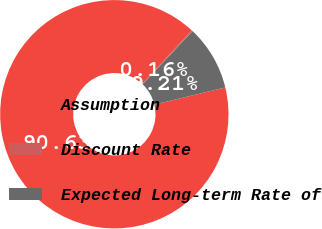<chart> <loc_0><loc_0><loc_500><loc_500><pie_chart><fcel>Assumption<fcel>Discount Rate<fcel>Expected Long-term Rate of<nl><fcel>90.63%<fcel>0.16%<fcel>9.21%<nl></chart> 